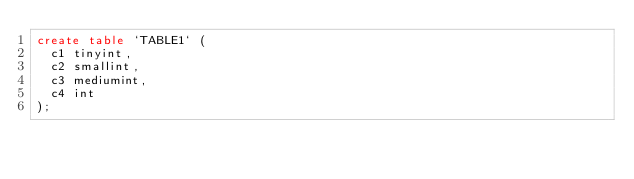<code> <loc_0><loc_0><loc_500><loc_500><_SQL_>create table `TABLE1` (
  c1 tinyint,
  c2 smallint,
  c3 mediumint,
  c4 int
);

</code> 